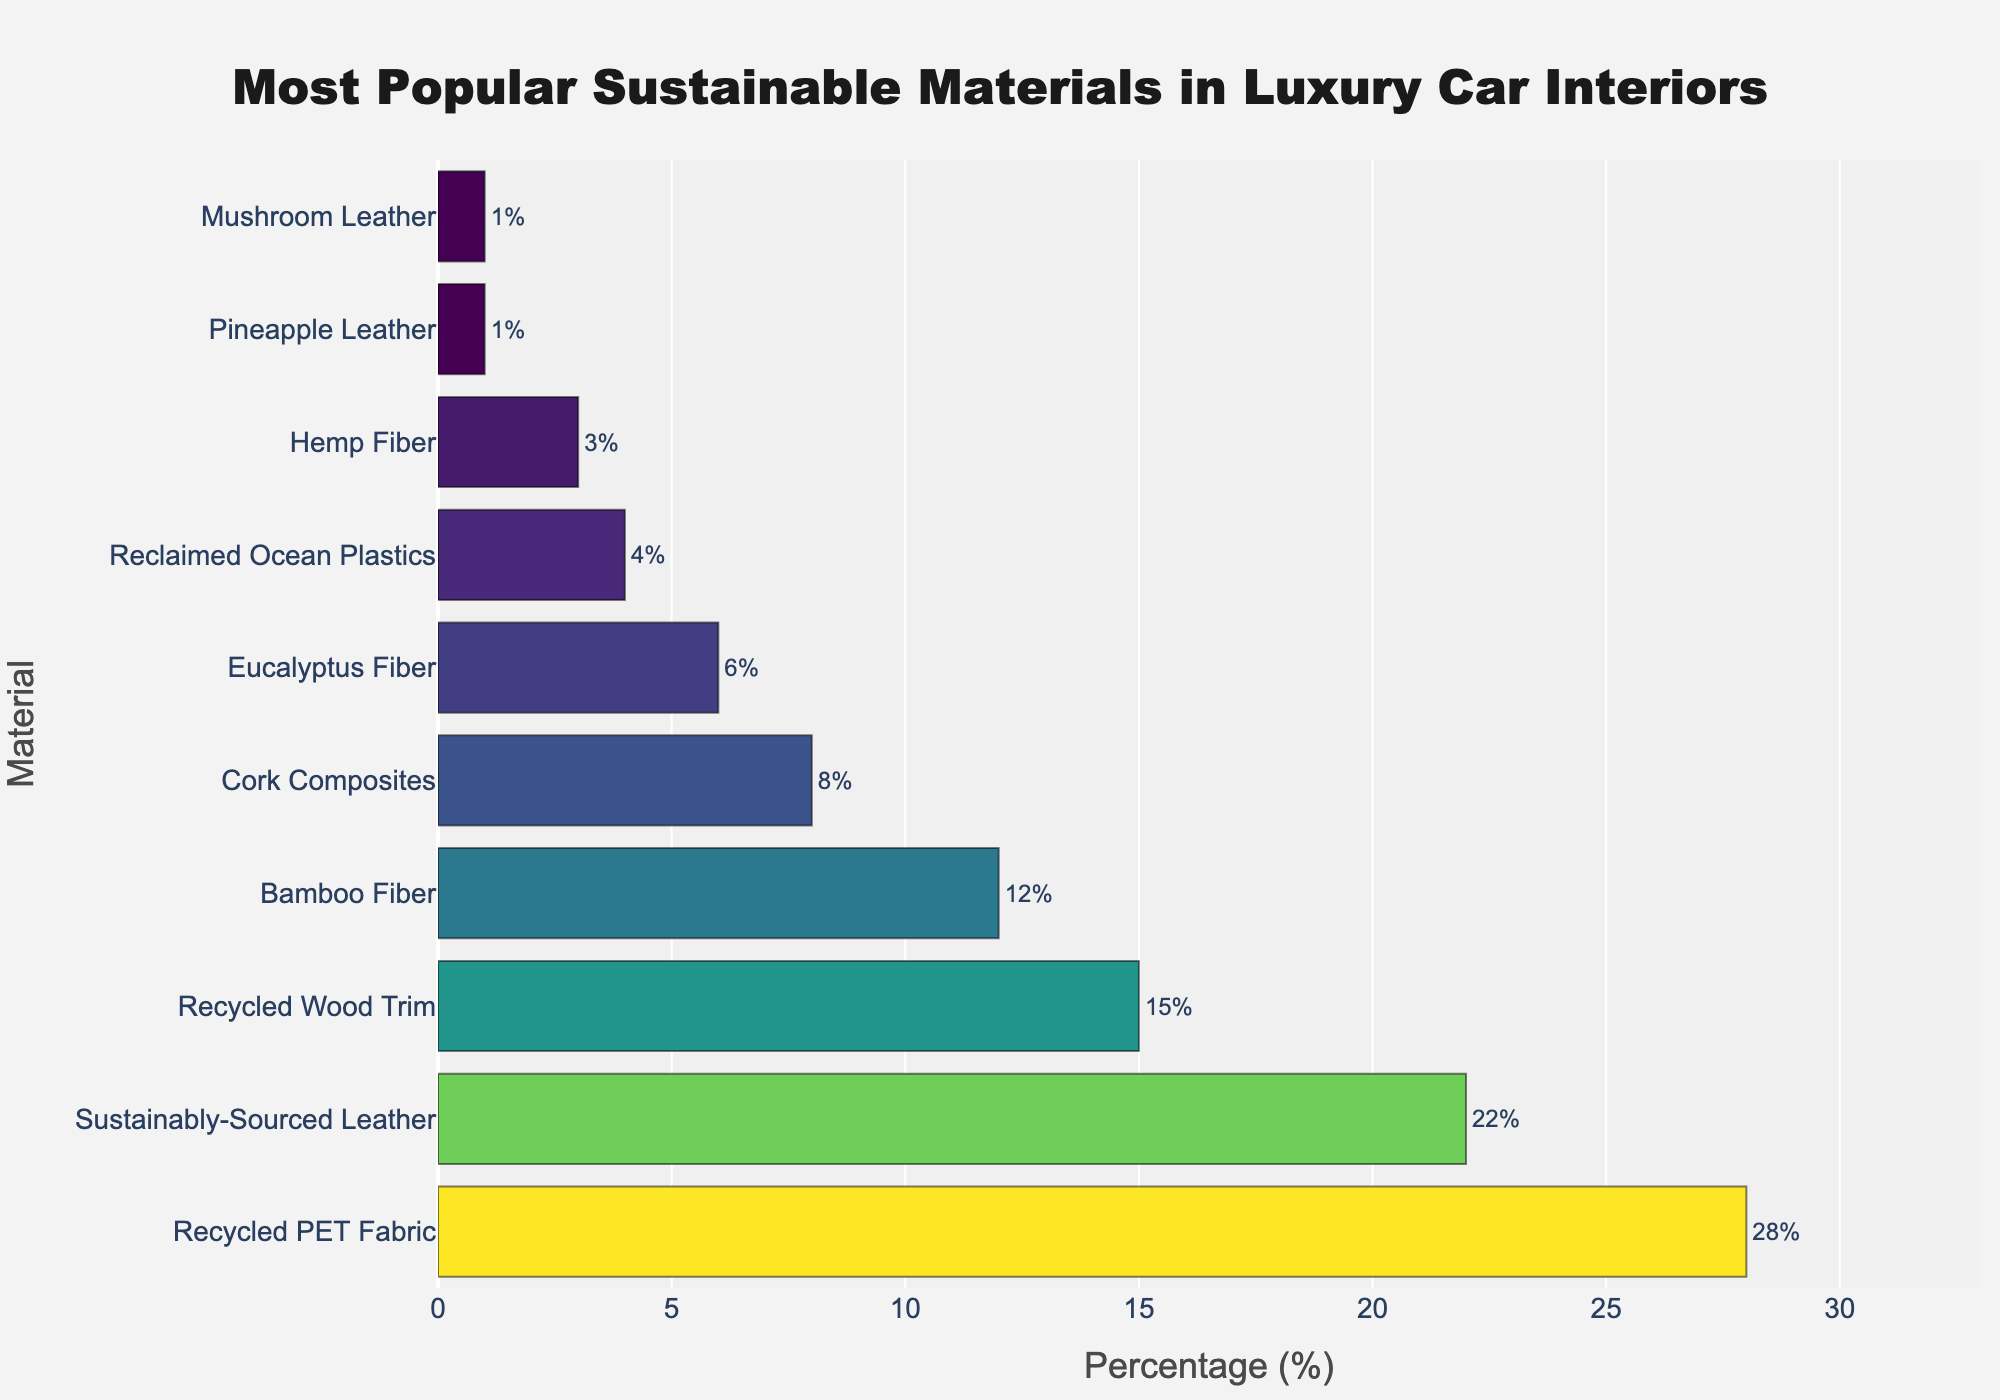Which material is the most popular for luxury car interiors? The most popular material will have the highest percentage value in the bar chart, which is the first bar from the top as the chart is sorted in descending order.
Answer: Recycled PET Fabric Which material is the least popular for luxury car interiors? The least popular material will have the lowest percentage value, which is the last bar from the top.
Answer: Mushroom Leather (tie with Pineapple Leather) How much more popular is Recycled PET Fabric compared to Hemp Fiber? Locate the bars for Recycled PET Fabric and Hemp Fiber. Recycled PET Fabric has 28%, and Hemp Fiber has 3%. Calculate the difference: 28% - 3% = 25%.
Answer: 25% Which is more popular, Bamboo Fiber or Cork Composites? Locate the bars for Bamboo Fiber and Cork Composites. Bamboo Fiber has 12%, and Cork Composites have 8%. Bamboo Fiber has a higher percentage.
Answer: Bamboo Fiber What is the combined percentage for materials sourced from plants (Bamboo Fiber, Eucalyptus Fiber, Hemp Fiber, Pineapple Leather, and Mushroom Leather)? Sum the percentages of Bamboo Fiber (12%), Eucalyptus Fiber (6%), Hemp Fiber (3%), Pineapple Leather (1%), and Mushroom Leather (1%) which is 12% + 6% + 3% + 1% + 1% = 23%.
Answer: 23% Which material has a percentage of 15%? Locate the bar with the percentage value of 15%.
Answer: Recycled Wood Trim How many materials have a percentage greater than or equal to 10%? Identify the bars with percentages 10% or higher: Recycled PET Fabric (28%), Sustainably-Sourced Leather (22%), Recycled Wood Trim (15%), Bamboo Fiber (12%). Count these, which total 4 materials.
Answer: 4 What is the average percentage of the three most popular materials? The three most popular materials are Recycled PET Fabric (28%), Sustainably-Sourced Leather (22%), and Recycled Wood Trim (15%). Calculate their average: (28% + 22% + 15%) / 3 ≈ 21.67%.
Answer: 21.67% Which materials have a percentage greater than 20%? Identify the bars that have a percentage greater than 20%. Recycled PET Fabric (28%) and Sustainably-Sourced Leather (22%).
Answer: Recycled PET Fabric, Sustainably-Sourced Leather By how much does the percentage of Reclaimed Ocean Plastics differ from that of Sustainably-Sourced Leather? The percentage for Reclaimed Ocean Plastics is 4%, and for Sustainably-Sourced Leather it is 22%. Calculate the difference: 22% - 4% = 18%.
Answer: 18% 